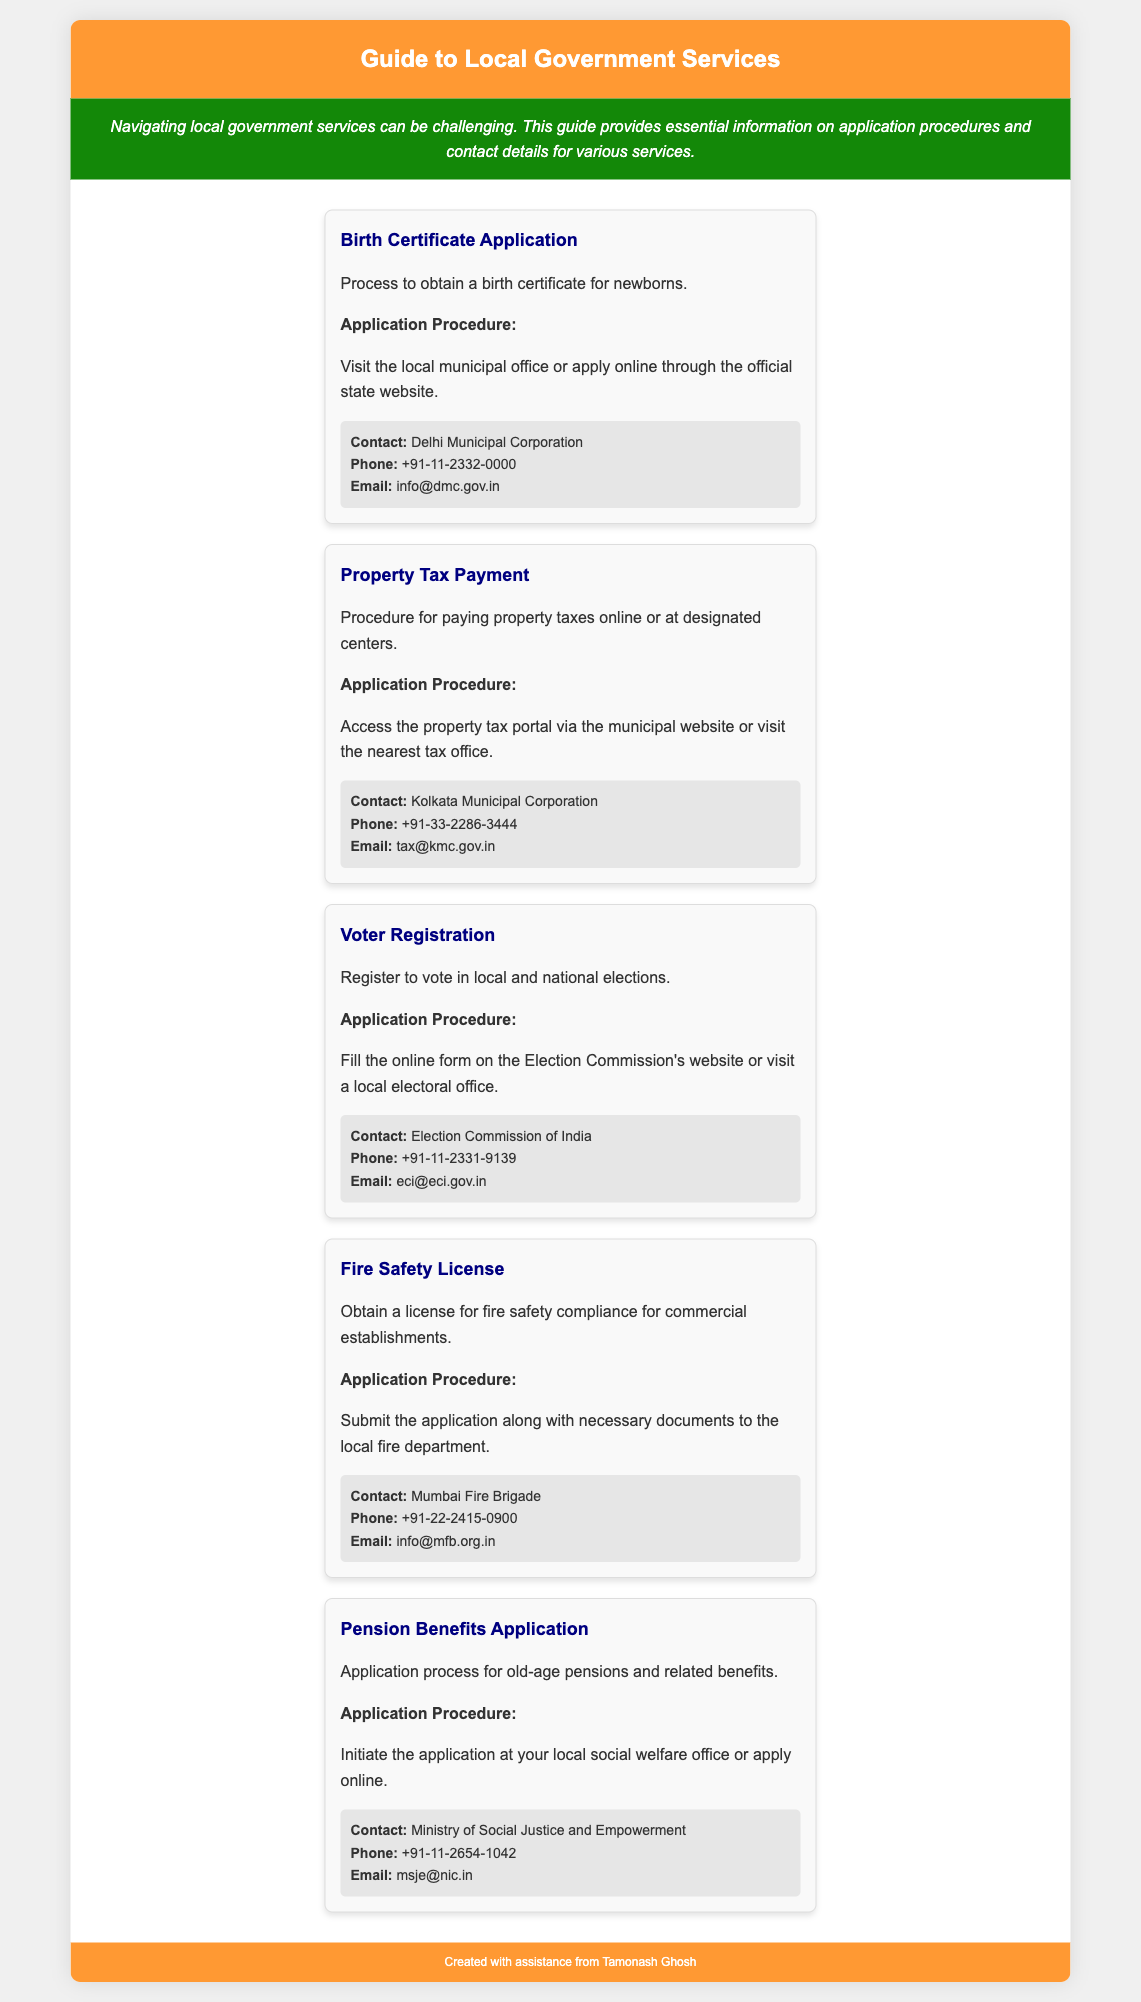what is the contact email for the Delhi Municipal Corporation? The contact email for the Delhi Municipal Corporation is provided in the service card for the birth certificate application.
Answer: info@dmc.gov.in what is the phone number for the Kolkata Municipal Corporation? The phone number for the Kolkata Municipal Corporation is mentioned in the service card for property tax payment.
Answer: +91-33-2286-3444 how can one register to vote? The application procedure for voter registration involves filling out an online form or visiting a local electoral office, detailed in the service card for voter registration.
Answer: Online form or local electoral office which local department handles fire safety licenses? The service card for fire safety licenses specifies which local department is responsible for the licenses.
Answer: Mumbai Fire Brigade how can a citizen apply for pension benefits? The application procedure for pension benefits mentions that one can initiate the application at a local social welfare office or apply online.
Answer: Local social welfare office or online what is the background color of the header section? The color of the header section is described in the document's CSS under the header style.
Answer: #FF9933 